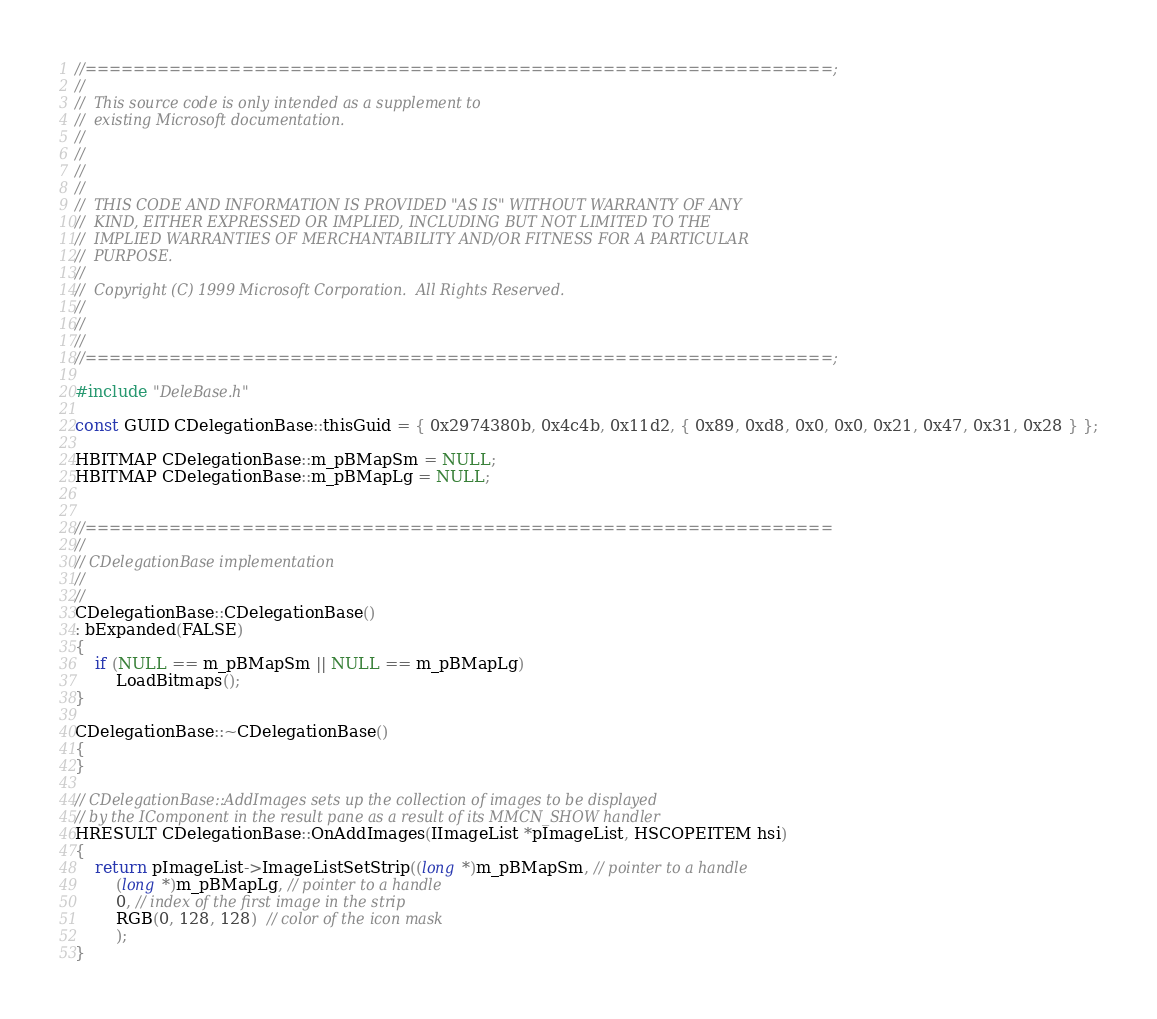<code> <loc_0><loc_0><loc_500><loc_500><_C++_>//==============================================================;
//
//	This source code is only intended as a supplement to 
//  existing Microsoft documentation. 
//
// 
//
//
//  THIS CODE AND INFORMATION IS PROVIDED "AS IS" WITHOUT WARRANTY OF ANY
//  KIND, EITHER EXPRESSED OR IMPLIED, INCLUDING BUT NOT LIMITED TO THE
//  IMPLIED WARRANTIES OF MERCHANTABILITY AND/OR FITNESS FOR A PARTICULAR
//  PURPOSE.
//
//  Copyright (C) 1999 Microsoft Corporation.  All Rights Reserved.
//
//
//
//==============================================================;

#include "DeleBase.h"

const GUID CDelegationBase::thisGuid = { 0x2974380b, 0x4c4b, 0x11d2, { 0x89, 0xd8, 0x0, 0x0, 0x21, 0x47, 0x31, 0x28 } };

HBITMAP CDelegationBase::m_pBMapSm = NULL;
HBITMAP CDelegationBase::m_pBMapLg = NULL;


//==============================================================
//
// CDelegationBase implementation
//
//
CDelegationBase::CDelegationBase() 
: bExpanded(FALSE) 
{ 
    if (NULL == m_pBMapSm || NULL == m_pBMapLg)
        LoadBitmaps(); 
}

CDelegationBase::~CDelegationBase() 
{ 
}

// CDelegationBase::AddImages sets up the collection of images to be displayed
// by the IComponent in the result pane as a result of its MMCN_SHOW handler
HRESULT CDelegationBase::OnAddImages(IImageList *pImageList, HSCOPEITEM hsi) 
{
    return pImageList->ImageListSetStrip((long *)m_pBMapSm, // pointer to a handle
        (long *)m_pBMapLg, // pointer to a handle
        0, // index of the first image in the strip
        RGB(0, 128, 128)  // color of the icon mask
        );
}
</code> 